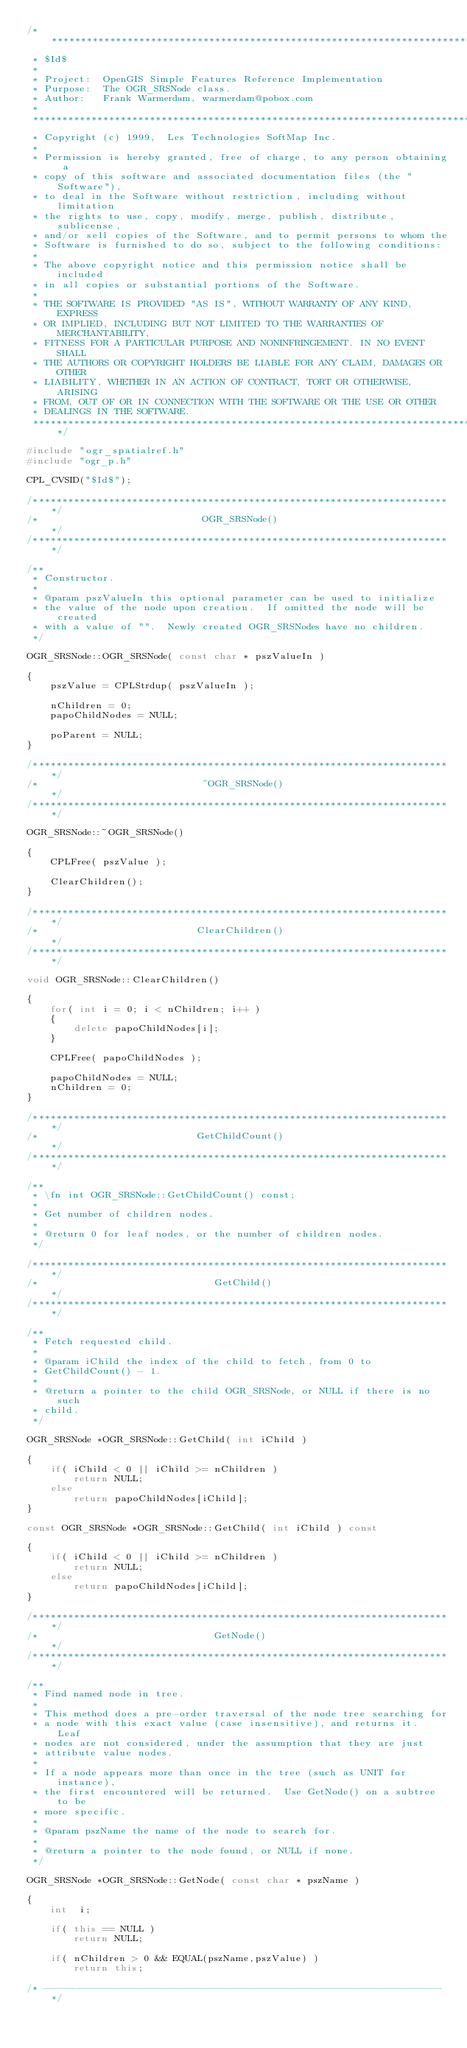Convert code to text. <code><loc_0><loc_0><loc_500><loc_500><_C++_>/******************************************************************************
 * $Id$
 *
 * Project:  OpenGIS Simple Features Reference Implementation
 * Purpose:  The OGR_SRSNode class.
 * Author:   Frank Warmerdam, warmerdam@pobox.com
 *
 ******************************************************************************
 * Copyright (c) 1999,  Les Technologies SoftMap Inc.
 *
 * Permission is hereby granted, free of charge, to any person obtaining a
 * copy of this software and associated documentation files (the "Software"),
 * to deal in the Software without restriction, including without limitation
 * the rights to use, copy, modify, merge, publish, distribute, sublicense,
 * and/or sell copies of the Software, and to permit persons to whom the
 * Software is furnished to do so, subject to the following conditions:
 *
 * The above copyright notice and this permission notice shall be included
 * in all copies or substantial portions of the Software.
 *
 * THE SOFTWARE IS PROVIDED "AS IS", WITHOUT WARRANTY OF ANY KIND, EXPRESS
 * OR IMPLIED, INCLUDING BUT NOT LIMITED TO THE WARRANTIES OF MERCHANTABILITY,
 * FITNESS FOR A PARTICULAR PURPOSE AND NONINFRINGEMENT. IN NO EVENT SHALL
 * THE AUTHORS OR COPYRIGHT HOLDERS BE LIABLE FOR ANY CLAIM, DAMAGES OR OTHER
 * LIABILITY, WHETHER IN AN ACTION OF CONTRACT, TORT OR OTHERWISE, ARISING
 * FROM, OUT OF OR IN CONNECTION WITH THE SOFTWARE OR THE USE OR OTHER
 * DEALINGS IN THE SOFTWARE.
 ****************************************************************************/

#include "ogr_spatialref.h"
#include "ogr_p.h"

CPL_CVSID("$Id$");

/************************************************************************/
/*                            OGR_SRSNode()                             */
/************************************************************************/

/**
 * Constructor.
 *
 * @param pszValueIn this optional parameter can be used to initialize
 * the value of the node upon creation.  If omitted the node will be created
 * with a value of "".  Newly created OGR_SRSNodes have no children.
 */

OGR_SRSNode::OGR_SRSNode( const char * pszValueIn )

{
    pszValue = CPLStrdup( pszValueIn );

    nChildren = 0;
    papoChildNodes = NULL;

    poParent = NULL;
}

/************************************************************************/
/*                            ~OGR_SRSNode()                            */
/************************************************************************/

OGR_SRSNode::~OGR_SRSNode()

{
    CPLFree( pszValue );

    ClearChildren();
}

/************************************************************************/
/*                           ClearChildren()                            */
/************************************************************************/

void OGR_SRSNode::ClearChildren()

{
    for( int i = 0; i < nChildren; i++ )
    {
        delete papoChildNodes[i];
    }

    CPLFree( papoChildNodes );

    papoChildNodes = NULL;
    nChildren = 0;
}

/************************************************************************/
/*                           GetChildCount()                            */
/************************************************************************/

/**
 * \fn int OGR_SRSNode::GetChildCount() const;
 *
 * Get number of children nodes.
 *
 * @return 0 for leaf nodes, or the number of children nodes. 
 */

/************************************************************************/
/*                              GetChild()                              */
/************************************************************************/

/**
 * Fetch requested child.
 *
 * @param iChild the index of the child to fetch, from 0 to
 * GetChildCount() - 1.
 *
 * @return a pointer to the child OGR_SRSNode, or NULL if there is no such
 * child. 
 */

OGR_SRSNode *OGR_SRSNode::GetChild( int iChild )

{
    if( iChild < 0 || iChild >= nChildren )
        return NULL;
    else
        return papoChildNodes[iChild];
}

const OGR_SRSNode *OGR_SRSNode::GetChild( int iChild ) const

{
    if( iChild < 0 || iChild >= nChildren )
        return NULL;
    else
        return papoChildNodes[iChild];
}

/************************************************************************/
/*                              GetNode()                               */
/************************************************************************/

/**
 * Find named node in tree.
 *
 * This method does a pre-order traversal of the node tree searching for
 * a node with this exact value (case insensitive), and returns it.  Leaf
 * nodes are not considered, under the assumption that they are just
 * attribute value nodes.
 *
 * If a node appears more than once in the tree (such as UNIT for instance),
 * the first encountered will be returned.  Use GetNode() on a subtree to be
 * more specific. 
 *
 * @param pszName the name of the node to search for.
 *
 * @return a pointer to the node found, or NULL if none.
 */

OGR_SRSNode *OGR_SRSNode::GetNode( const char * pszName )

{
    int  i;

    if( this == NULL )
        return NULL;
    
    if( nChildren > 0 && EQUAL(pszName,pszValue) )
        return this;

/* -------------------------------------------------------------------- */</code> 